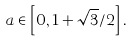<formula> <loc_0><loc_0><loc_500><loc_500>a \in \left [ 0 , 1 + \sqrt { 3 } / 2 \right ] .</formula> 